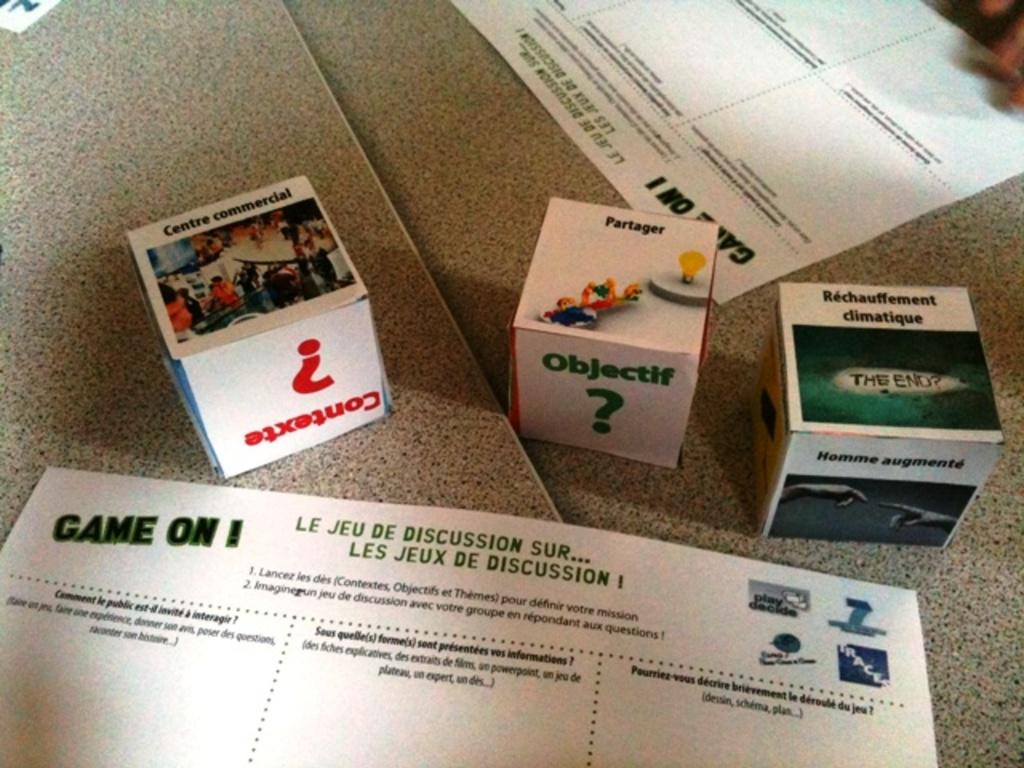What objects are on the ground in the image? There are boxes and papers on the ground. Can you describe the boxes in the image? The boxes are on the ground, but their specific characteristics are not mentioned in the provided facts. What else is present on the ground besides the boxes? Papers are also present on the ground. What type of cabbage is being used as a hat in the image? There is no cabbage or hat present in the image. How many crackers are visible on the ground in the image? There is no mention of crackers in the provided facts, so we cannot determine their presence or quantity in the image. 